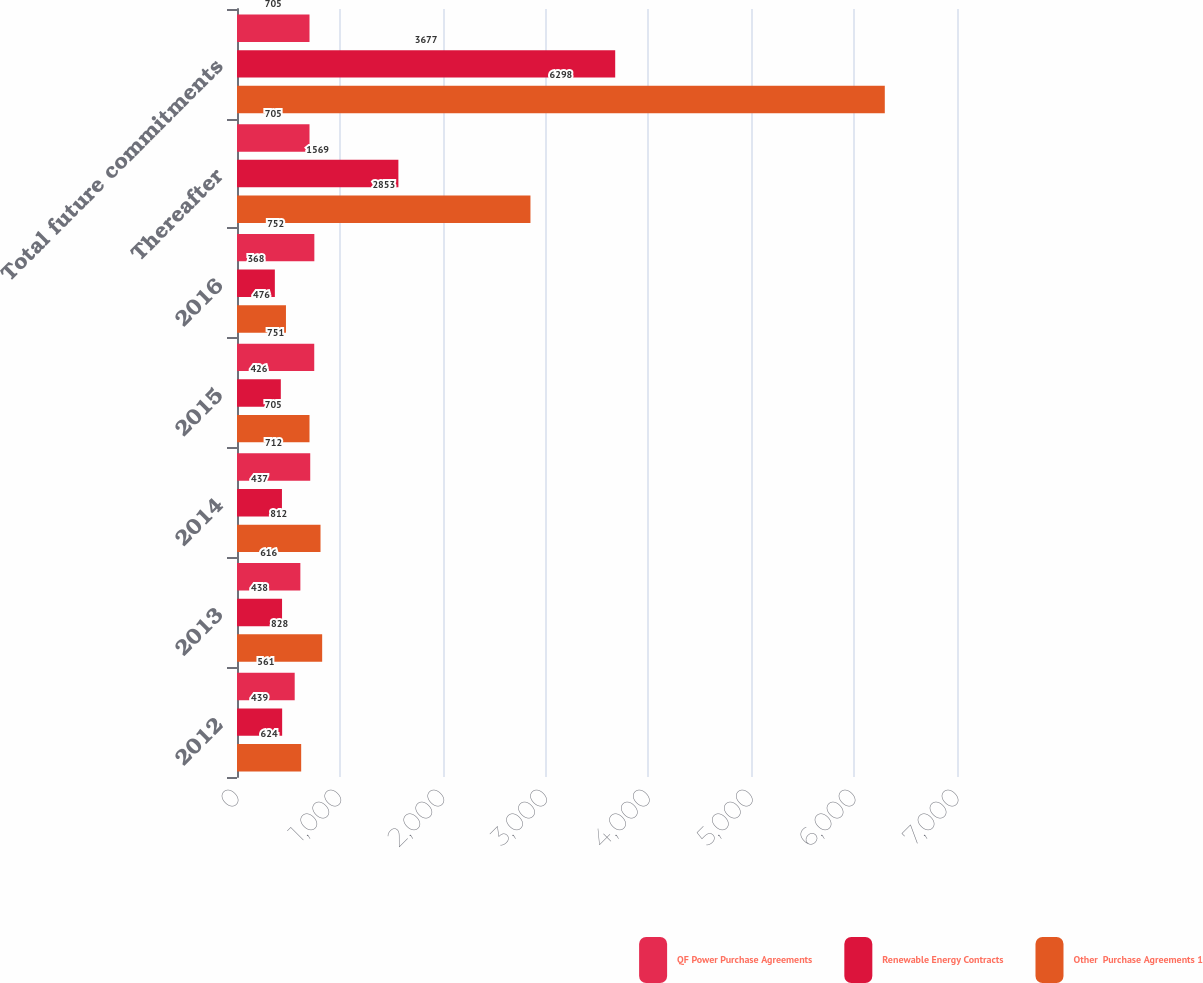Convert chart to OTSL. <chart><loc_0><loc_0><loc_500><loc_500><stacked_bar_chart><ecel><fcel>2012<fcel>2013<fcel>2014<fcel>2015<fcel>2016<fcel>Thereafter<fcel>Total future commitments<nl><fcel>QF Power Purchase Agreements<fcel>561<fcel>616<fcel>712<fcel>751<fcel>752<fcel>705<fcel>705<nl><fcel>Renewable Energy Contracts<fcel>439<fcel>438<fcel>437<fcel>426<fcel>368<fcel>1569<fcel>3677<nl><fcel>Other  Purchase Agreements 1<fcel>624<fcel>828<fcel>812<fcel>705<fcel>476<fcel>2853<fcel>6298<nl></chart> 